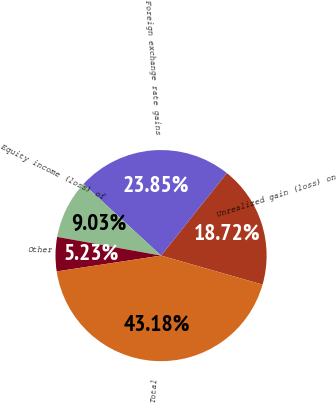Convert chart. <chart><loc_0><loc_0><loc_500><loc_500><pie_chart><fcel>Unrealized gain (loss) on<fcel>Foreign exchange rate gains<fcel>Equity income (loss) of<fcel>Other<fcel>Total<nl><fcel>18.72%<fcel>23.85%<fcel>9.03%<fcel>5.23%<fcel>43.18%<nl></chart> 